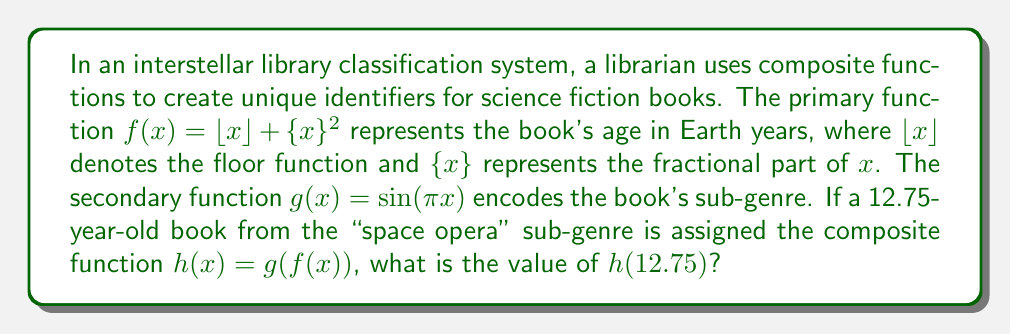Can you answer this question? Let's approach this step-by-step:

1) First, we need to calculate $f(12.75)$:
   
   $f(12.75) = \lfloor 12.75 \rfloor + \{12.75\}^2$

2) $\lfloor 12.75 \rfloor = 12$ (the floor function gives the largest integer less than or equal to 12.75)

3) $\{12.75\} = 12.75 - 12 = 0.75$ (the fractional part)

4) So, $f(12.75) = 12 + (0.75)^2 = 12 + 0.5625 = 12.5625$

5) Now we need to calculate $g(f(12.75))$, which is equivalent to $g(12.5625)$:
   
   $g(12.5625) = \sin(\pi \cdot 12.5625)$

6) $\pi \cdot 12.5625 = 39.4513...$ radians

7) $\sin(39.4513...) = \sin(3.4513...)$ (because sine has a period of $2\pi$)

8) $\sin(3.4513...) \approx -0.9877$

Therefore, $h(12.75) = g(f(12.75)) \approx -0.9877$
Answer: $-0.9877$ 